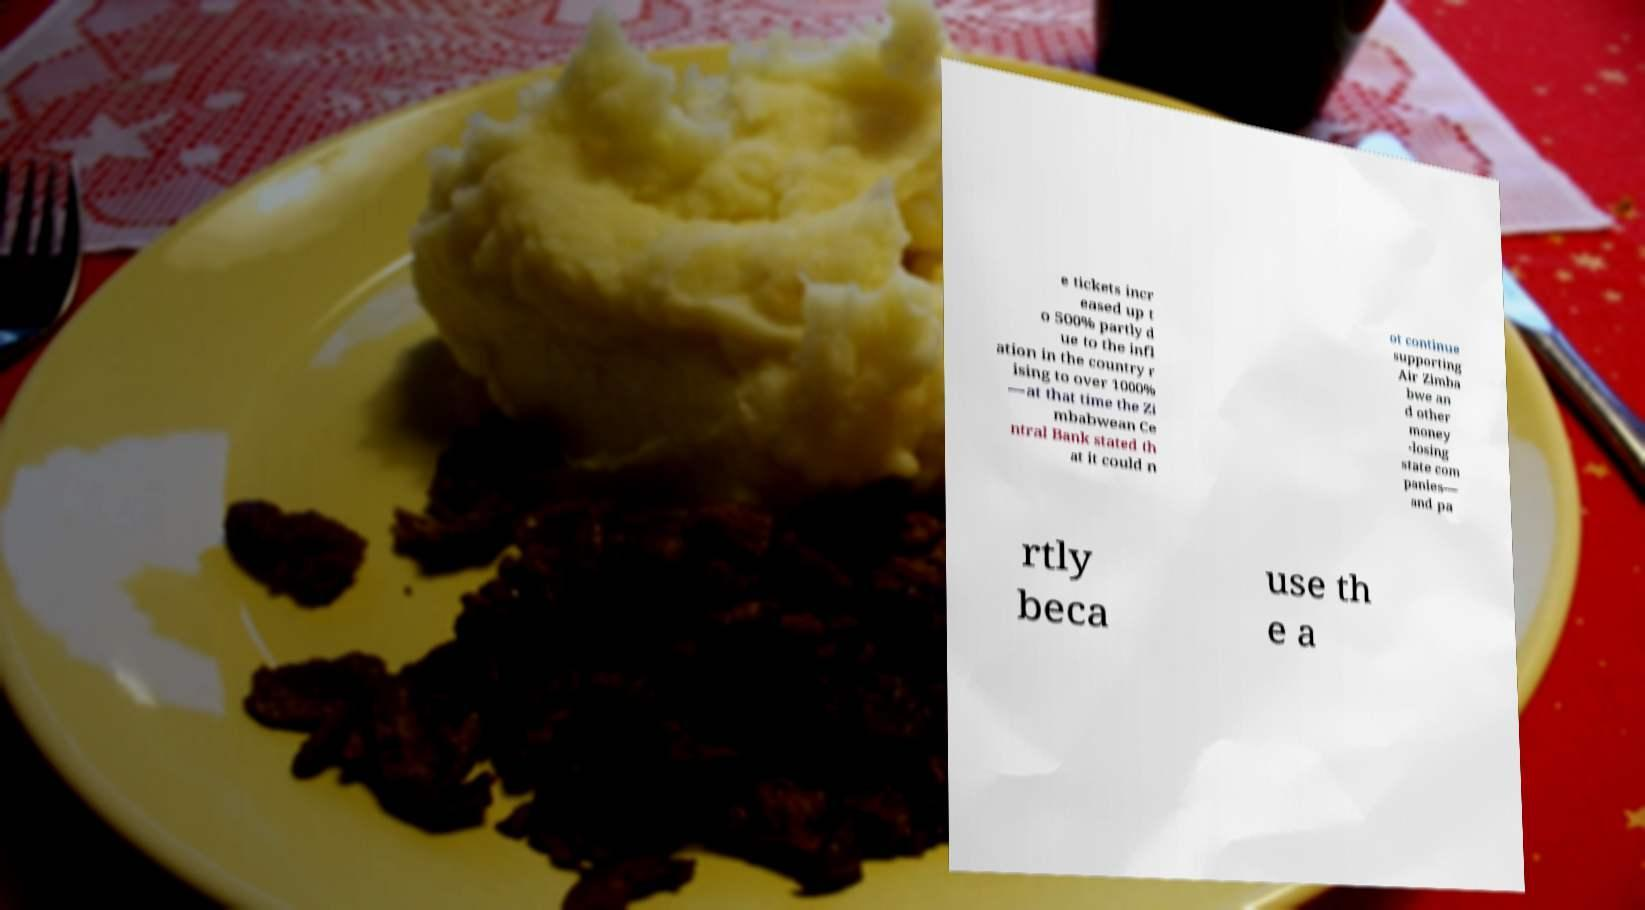What messages or text are displayed in this image? I need them in a readable, typed format. e tickets incr eased up t o 500% partly d ue to the infl ation in the country r ising to over 1000% —at that time the Zi mbabwean Ce ntral Bank stated th at it could n ot continue supporting Air Zimba bwe an d other money -losing state com panies— and pa rtly beca use th e a 